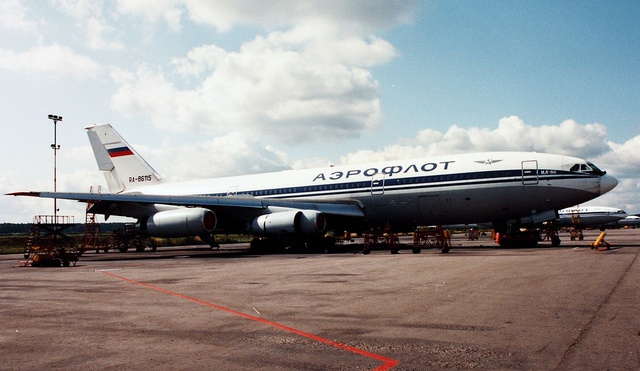Describe the objects in this image and their specific colors. I can see airplane in white, black, darkgray, and gray tones and airplane in white, black, gray, and darkgray tones in this image. 